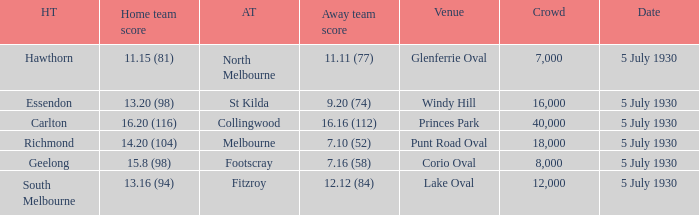What is the venue when fitzroy was the away team? Lake Oval. 